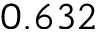Convert formula to latex. <formula><loc_0><loc_0><loc_500><loc_500>0 . 6 3 2</formula> 